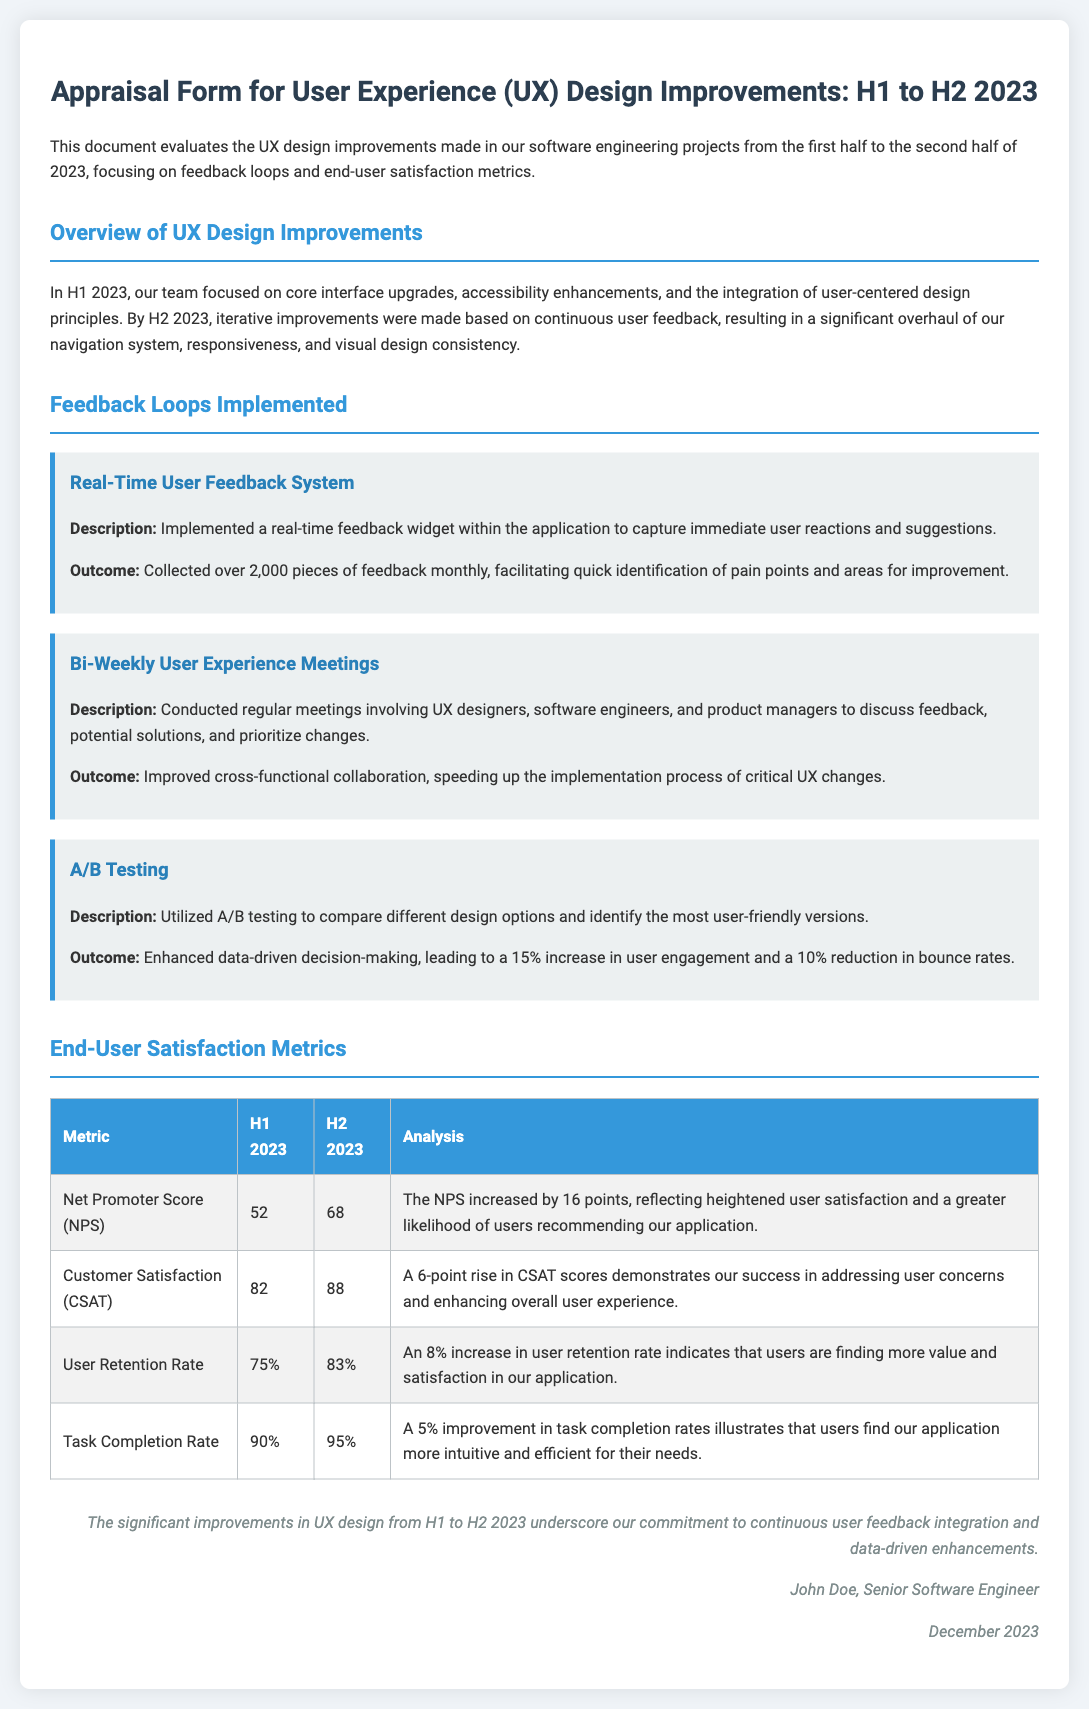what is the title of the document? The title is provided in the header of the document.
Answer: Appraisal Form for User Experience (UX) Design Improvements: H1 to H2 2023 how many pieces of feedback were collected monthly after implementation of the Real-Time User Feedback System? The document states the amount of feedback collected after the system was put in place.
Answer: over 2,000 what was the increase in Net Promoter Score from H1 to H2 2023? The change in Customer Satisfaction is detailed in the metrics table, showing the NPS for both halves.
Answer: 16 points what percentage of users completed tasks in H1 2023? The Task Completion Rate for H1 2023 is listed in the metrics table.
Answer: 90% what was the outcome of A/B Testing as stated in the document? The document outlines specific outcomes from the A/B Testing feedback loop.
Answer: 15% increase in user engagement what was the User Retention Rate in H2 2023? This is found in the End-User Satisfaction Metrics section of the document.
Answer: 83% what is the purpose of Bi-Weekly User Experience Meetings? The document specifies the aim of these meetings in the context of UX improvements.
Answer: Discuss feedback and prioritize changes how many metrics are compared in the end-user satisfaction metrics table? The metrics table provides a clear count of the metrics analyzed.
Answer: 4 metrics 